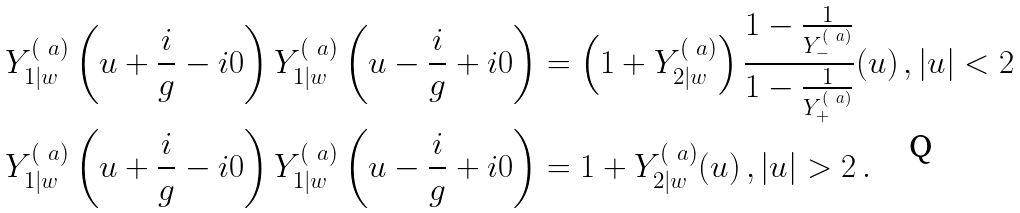Convert formula to latex. <formula><loc_0><loc_0><loc_500><loc_500>Y _ { 1 | w } ^ { ( \ a ) } \left ( u + \frac { i } { g } - i 0 \right ) Y _ { 1 | w } ^ { ( \ a ) } \left ( u - \frac { i } { g } + i 0 \right ) & = \left ( 1 + Y _ { 2 | w } ^ { ( \ a ) } \right ) \frac { 1 - \frac { 1 } { Y _ { - } ^ { ( \ a ) } } } { 1 - \frac { 1 } { Y _ { + } ^ { ( \ a ) } } } ( u ) \, , | u | < 2 \\ Y _ { 1 | w } ^ { ( \ a ) } \left ( u + \frac { i } { g } - i 0 \right ) Y _ { 1 | w } ^ { ( \ a ) } \left ( u - \frac { i } { g } + i 0 \right ) & = 1 + Y _ { 2 | w } ^ { ( \ a ) } ( u ) \, , | u | > 2 \, .</formula> 